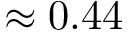Convert formula to latex. <formula><loc_0><loc_0><loc_500><loc_500>\approx 0 . 4 4</formula> 